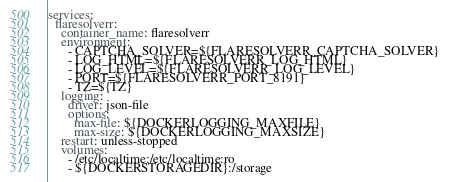Convert code to text. <code><loc_0><loc_0><loc_500><loc_500><_YAML_>services:
  flaresolverr:
    container_name: flaresolverr
    environment:
      - CAPTCHA_SOLVER=${FLARESOLVERR_CAPTCHA_SOLVER}
      - LOG_HTML=${FLARESOLVERR_LOG_HTML}
      - LOG_LEVEL=${FLARESOLVERR_LOG_LEVEL}
      - PORT=${FLARESOLVERR_PORT_8191}
      - TZ=${TZ}
    logging:
      driver: json-file
      options:
        max-file: ${DOCKERLOGGING_MAXFILE}
        max-size: ${DOCKERLOGGING_MAXSIZE}
    restart: unless-stopped
    volumes:
      - /etc/localtime:/etc/localtime:ro
      - ${DOCKERSTORAGEDIR}:/storage
</code> 